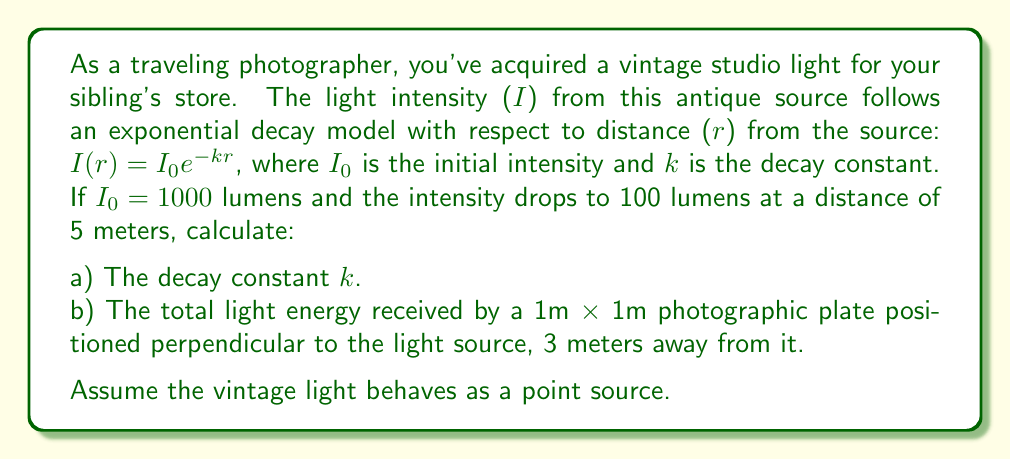Can you answer this question? Let's approach this problem step by step:

a) To find the decay constant $k$:

We know that at $r = 5$ meters, $I = 100$ lumens. We can use the given equation:

$I(r) = I_0e^{-kr}$

Substituting the values:

$100 = 1000e^{-k(5)}$

Dividing both sides by 1000:

$0.1 = e^{-5k}$

Taking natural logarithm of both sides:

$\ln(0.1) = -5k$

$k = -\frac{\ln(0.1)}{5} \approx 0.4605$ m$^{-1}$

b) To calculate the total light energy received by the photographic plate:

We need to integrate the intensity function over the area of the plate. Since the plate is perpendicular to the light source and 3 meters away, all points on the plate are 3 meters from the source.

The intensity at 3 meters is:

$I(3) = 1000e^{-0.4605(3)} \approx 252.94$ lumens/m$^2$

The energy received by the plate is this intensity multiplied by its area:

$E = 252.94 \times 1 \times 1 = 252.94$ lumens

Note: In reality, the intensity would vary slightly across the plate due to the inverse square law, but given the point source assumption and the relatively small plate size compared to the distance, this approximation is reasonable.
Answer: a) $k \approx 0.4605$ m$^{-1}$
b) $E \approx 252.94$ lumens 